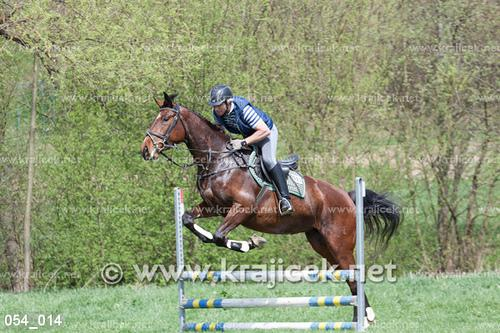Question: why was the photo taken?
Choices:
A. For a yearbook.
B. For a graduation announcement.
C. For a magazine.
D. For a picture frame.
Answer with the letter. Answer: C 